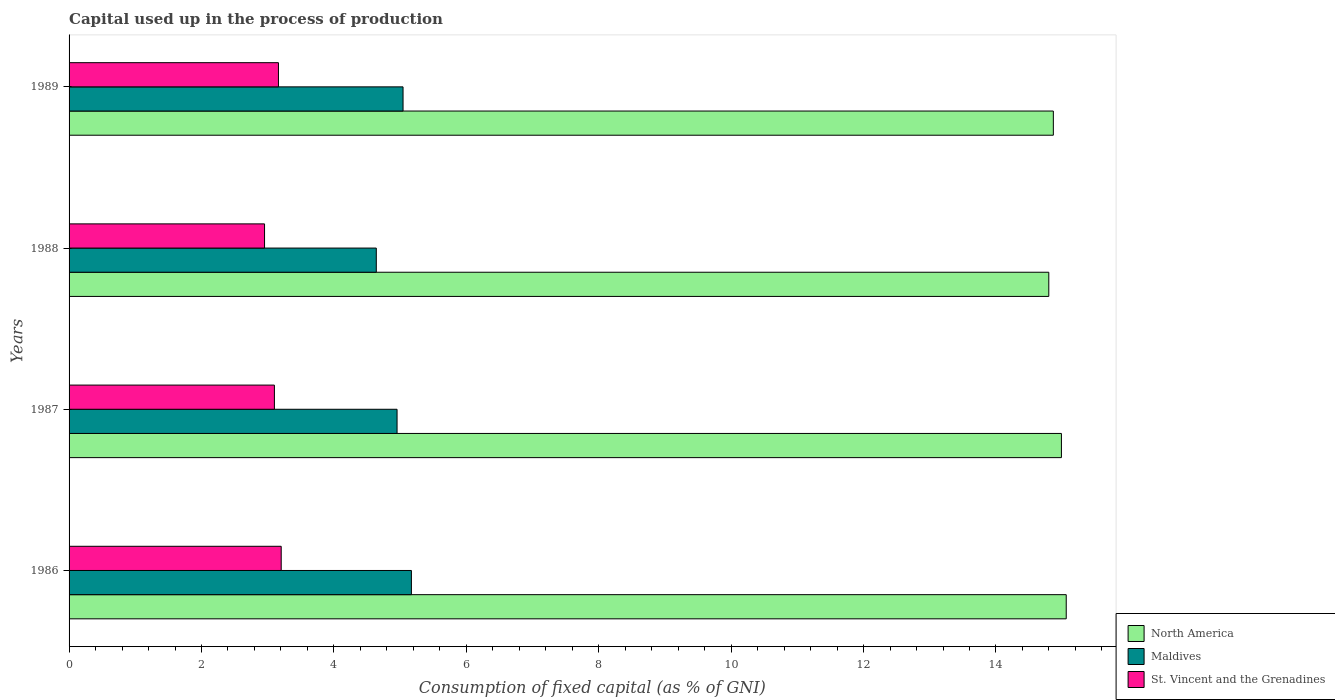How many groups of bars are there?
Your response must be concise. 4. How many bars are there on the 2nd tick from the top?
Give a very brief answer. 3. How many bars are there on the 4th tick from the bottom?
Ensure brevity in your answer.  3. What is the label of the 1st group of bars from the top?
Give a very brief answer. 1989. In how many cases, is the number of bars for a given year not equal to the number of legend labels?
Ensure brevity in your answer.  0. What is the capital used up in the process of production in Maldives in 1986?
Offer a terse response. 5.17. Across all years, what is the maximum capital used up in the process of production in North America?
Your answer should be very brief. 15.06. Across all years, what is the minimum capital used up in the process of production in North America?
Give a very brief answer. 14.8. In which year was the capital used up in the process of production in North America maximum?
Ensure brevity in your answer.  1986. In which year was the capital used up in the process of production in St. Vincent and the Grenadines minimum?
Offer a terse response. 1988. What is the total capital used up in the process of production in North America in the graph?
Keep it short and to the point. 59.71. What is the difference between the capital used up in the process of production in North America in 1988 and that in 1989?
Give a very brief answer. -0.07. What is the difference between the capital used up in the process of production in Maldives in 1987 and the capital used up in the process of production in St. Vincent and the Grenadines in 1986?
Provide a short and direct response. 1.75. What is the average capital used up in the process of production in St. Vincent and the Grenadines per year?
Provide a short and direct response. 3.11. In the year 1989, what is the difference between the capital used up in the process of production in North America and capital used up in the process of production in Maldives?
Give a very brief answer. 9.82. What is the ratio of the capital used up in the process of production in Maldives in 1986 to that in 1987?
Offer a terse response. 1.04. Is the capital used up in the process of production in Maldives in 1988 less than that in 1989?
Give a very brief answer. Yes. What is the difference between the highest and the second highest capital used up in the process of production in North America?
Provide a succinct answer. 0.07. What is the difference between the highest and the lowest capital used up in the process of production in Maldives?
Your response must be concise. 0.53. Is the sum of the capital used up in the process of production in Maldives in 1987 and 1988 greater than the maximum capital used up in the process of production in North America across all years?
Give a very brief answer. No. What does the 3rd bar from the top in 1986 represents?
Your answer should be compact. North America. What does the 1st bar from the bottom in 1987 represents?
Ensure brevity in your answer.  North America. Is it the case that in every year, the sum of the capital used up in the process of production in North America and capital used up in the process of production in Maldives is greater than the capital used up in the process of production in St. Vincent and the Grenadines?
Ensure brevity in your answer.  Yes. How many years are there in the graph?
Your answer should be very brief. 4. Are the values on the major ticks of X-axis written in scientific E-notation?
Offer a very short reply. No. Does the graph contain grids?
Your answer should be compact. No. How are the legend labels stacked?
Make the answer very short. Vertical. What is the title of the graph?
Offer a very short reply. Capital used up in the process of production. What is the label or title of the X-axis?
Provide a succinct answer. Consumption of fixed capital (as % of GNI). What is the label or title of the Y-axis?
Your answer should be compact. Years. What is the Consumption of fixed capital (as % of GNI) in North America in 1986?
Provide a short and direct response. 15.06. What is the Consumption of fixed capital (as % of GNI) in Maldives in 1986?
Provide a succinct answer. 5.17. What is the Consumption of fixed capital (as % of GNI) in St. Vincent and the Grenadines in 1986?
Your answer should be compact. 3.2. What is the Consumption of fixed capital (as % of GNI) of North America in 1987?
Ensure brevity in your answer.  14.99. What is the Consumption of fixed capital (as % of GNI) of Maldives in 1987?
Offer a very short reply. 4.95. What is the Consumption of fixed capital (as % of GNI) of St. Vincent and the Grenadines in 1987?
Your response must be concise. 3.1. What is the Consumption of fixed capital (as % of GNI) of North America in 1988?
Ensure brevity in your answer.  14.8. What is the Consumption of fixed capital (as % of GNI) in Maldives in 1988?
Your answer should be compact. 4.64. What is the Consumption of fixed capital (as % of GNI) of St. Vincent and the Grenadines in 1988?
Your answer should be compact. 2.95. What is the Consumption of fixed capital (as % of GNI) of North America in 1989?
Provide a succinct answer. 14.87. What is the Consumption of fixed capital (as % of GNI) in Maldives in 1989?
Offer a very short reply. 5.04. What is the Consumption of fixed capital (as % of GNI) of St. Vincent and the Grenadines in 1989?
Your answer should be very brief. 3.16. Across all years, what is the maximum Consumption of fixed capital (as % of GNI) in North America?
Give a very brief answer. 15.06. Across all years, what is the maximum Consumption of fixed capital (as % of GNI) of Maldives?
Provide a short and direct response. 5.17. Across all years, what is the maximum Consumption of fixed capital (as % of GNI) in St. Vincent and the Grenadines?
Offer a very short reply. 3.2. Across all years, what is the minimum Consumption of fixed capital (as % of GNI) of North America?
Offer a very short reply. 14.8. Across all years, what is the minimum Consumption of fixed capital (as % of GNI) of Maldives?
Provide a short and direct response. 4.64. Across all years, what is the minimum Consumption of fixed capital (as % of GNI) in St. Vincent and the Grenadines?
Offer a very short reply. 2.95. What is the total Consumption of fixed capital (as % of GNI) of North America in the graph?
Make the answer very short. 59.71. What is the total Consumption of fixed capital (as % of GNI) in Maldives in the graph?
Keep it short and to the point. 19.81. What is the total Consumption of fixed capital (as % of GNI) of St. Vincent and the Grenadines in the graph?
Give a very brief answer. 12.42. What is the difference between the Consumption of fixed capital (as % of GNI) of North America in 1986 and that in 1987?
Keep it short and to the point. 0.07. What is the difference between the Consumption of fixed capital (as % of GNI) of Maldives in 1986 and that in 1987?
Provide a short and direct response. 0.22. What is the difference between the Consumption of fixed capital (as % of GNI) in St. Vincent and the Grenadines in 1986 and that in 1987?
Offer a terse response. 0.1. What is the difference between the Consumption of fixed capital (as % of GNI) in North America in 1986 and that in 1988?
Your answer should be very brief. 0.26. What is the difference between the Consumption of fixed capital (as % of GNI) in Maldives in 1986 and that in 1988?
Provide a short and direct response. 0.53. What is the difference between the Consumption of fixed capital (as % of GNI) of St. Vincent and the Grenadines in 1986 and that in 1988?
Offer a terse response. 0.25. What is the difference between the Consumption of fixed capital (as % of GNI) of North America in 1986 and that in 1989?
Give a very brief answer. 0.19. What is the difference between the Consumption of fixed capital (as % of GNI) of Maldives in 1986 and that in 1989?
Your answer should be compact. 0.13. What is the difference between the Consumption of fixed capital (as % of GNI) of St. Vincent and the Grenadines in 1986 and that in 1989?
Your response must be concise. 0.04. What is the difference between the Consumption of fixed capital (as % of GNI) of North America in 1987 and that in 1988?
Ensure brevity in your answer.  0.19. What is the difference between the Consumption of fixed capital (as % of GNI) in Maldives in 1987 and that in 1988?
Offer a terse response. 0.31. What is the difference between the Consumption of fixed capital (as % of GNI) in St. Vincent and the Grenadines in 1987 and that in 1988?
Your response must be concise. 0.15. What is the difference between the Consumption of fixed capital (as % of GNI) of North America in 1987 and that in 1989?
Your answer should be very brief. 0.12. What is the difference between the Consumption of fixed capital (as % of GNI) of Maldives in 1987 and that in 1989?
Keep it short and to the point. -0.09. What is the difference between the Consumption of fixed capital (as % of GNI) in St. Vincent and the Grenadines in 1987 and that in 1989?
Provide a succinct answer. -0.06. What is the difference between the Consumption of fixed capital (as % of GNI) in North America in 1988 and that in 1989?
Ensure brevity in your answer.  -0.07. What is the difference between the Consumption of fixed capital (as % of GNI) of Maldives in 1988 and that in 1989?
Make the answer very short. -0.4. What is the difference between the Consumption of fixed capital (as % of GNI) of St. Vincent and the Grenadines in 1988 and that in 1989?
Your answer should be compact. -0.21. What is the difference between the Consumption of fixed capital (as % of GNI) of North America in 1986 and the Consumption of fixed capital (as % of GNI) of Maldives in 1987?
Give a very brief answer. 10.11. What is the difference between the Consumption of fixed capital (as % of GNI) in North America in 1986 and the Consumption of fixed capital (as % of GNI) in St. Vincent and the Grenadines in 1987?
Your answer should be compact. 11.96. What is the difference between the Consumption of fixed capital (as % of GNI) in Maldives in 1986 and the Consumption of fixed capital (as % of GNI) in St. Vincent and the Grenadines in 1987?
Keep it short and to the point. 2.07. What is the difference between the Consumption of fixed capital (as % of GNI) in North America in 1986 and the Consumption of fixed capital (as % of GNI) in Maldives in 1988?
Your answer should be compact. 10.42. What is the difference between the Consumption of fixed capital (as % of GNI) in North America in 1986 and the Consumption of fixed capital (as % of GNI) in St. Vincent and the Grenadines in 1988?
Make the answer very short. 12.11. What is the difference between the Consumption of fixed capital (as % of GNI) of Maldives in 1986 and the Consumption of fixed capital (as % of GNI) of St. Vincent and the Grenadines in 1988?
Give a very brief answer. 2.22. What is the difference between the Consumption of fixed capital (as % of GNI) in North America in 1986 and the Consumption of fixed capital (as % of GNI) in Maldives in 1989?
Make the answer very short. 10.02. What is the difference between the Consumption of fixed capital (as % of GNI) of North America in 1986 and the Consumption of fixed capital (as % of GNI) of St. Vincent and the Grenadines in 1989?
Offer a very short reply. 11.9. What is the difference between the Consumption of fixed capital (as % of GNI) in Maldives in 1986 and the Consumption of fixed capital (as % of GNI) in St. Vincent and the Grenadines in 1989?
Offer a very short reply. 2.01. What is the difference between the Consumption of fixed capital (as % of GNI) in North America in 1987 and the Consumption of fixed capital (as % of GNI) in Maldives in 1988?
Offer a terse response. 10.35. What is the difference between the Consumption of fixed capital (as % of GNI) of North America in 1987 and the Consumption of fixed capital (as % of GNI) of St. Vincent and the Grenadines in 1988?
Your answer should be compact. 12.04. What is the difference between the Consumption of fixed capital (as % of GNI) of Maldives in 1987 and the Consumption of fixed capital (as % of GNI) of St. Vincent and the Grenadines in 1988?
Ensure brevity in your answer.  2. What is the difference between the Consumption of fixed capital (as % of GNI) of North America in 1987 and the Consumption of fixed capital (as % of GNI) of Maldives in 1989?
Offer a terse response. 9.94. What is the difference between the Consumption of fixed capital (as % of GNI) in North America in 1987 and the Consumption of fixed capital (as % of GNI) in St. Vincent and the Grenadines in 1989?
Keep it short and to the point. 11.83. What is the difference between the Consumption of fixed capital (as % of GNI) in Maldives in 1987 and the Consumption of fixed capital (as % of GNI) in St. Vincent and the Grenadines in 1989?
Provide a succinct answer. 1.79. What is the difference between the Consumption of fixed capital (as % of GNI) in North America in 1988 and the Consumption of fixed capital (as % of GNI) in Maldives in 1989?
Provide a succinct answer. 9.75. What is the difference between the Consumption of fixed capital (as % of GNI) in North America in 1988 and the Consumption of fixed capital (as % of GNI) in St. Vincent and the Grenadines in 1989?
Ensure brevity in your answer.  11.64. What is the difference between the Consumption of fixed capital (as % of GNI) of Maldives in 1988 and the Consumption of fixed capital (as % of GNI) of St. Vincent and the Grenadines in 1989?
Offer a very short reply. 1.48. What is the average Consumption of fixed capital (as % of GNI) in North America per year?
Your response must be concise. 14.93. What is the average Consumption of fixed capital (as % of GNI) of Maldives per year?
Your response must be concise. 4.95. What is the average Consumption of fixed capital (as % of GNI) of St. Vincent and the Grenadines per year?
Give a very brief answer. 3.11. In the year 1986, what is the difference between the Consumption of fixed capital (as % of GNI) of North America and Consumption of fixed capital (as % of GNI) of Maldives?
Give a very brief answer. 9.89. In the year 1986, what is the difference between the Consumption of fixed capital (as % of GNI) of North America and Consumption of fixed capital (as % of GNI) of St. Vincent and the Grenadines?
Provide a short and direct response. 11.86. In the year 1986, what is the difference between the Consumption of fixed capital (as % of GNI) of Maldives and Consumption of fixed capital (as % of GNI) of St. Vincent and the Grenadines?
Your answer should be compact. 1.97. In the year 1987, what is the difference between the Consumption of fixed capital (as % of GNI) of North America and Consumption of fixed capital (as % of GNI) of Maldives?
Your answer should be compact. 10.03. In the year 1987, what is the difference between the Consumption of fixed capital (as % of GNI) in North America and Consumption of fixed capital (as % of GNI) in St. Vincent and the Grenadines?
Your answer should be very brief. 11.89. In the year 1987, what is the difference between the Consumption of fixed capital (as % of GNI) of Maldives and Consumption of fixed capital (as % of GNI) of St. Vincent and the Grenadines?
Give a very brief answer. 1.85. In the year 1988, what is the difference between the Consumption of fixed capital (as % of GNI) in North America and Consumption of fixed capital (as % of GNI) in Maldives?
Your response must be concise. 10.16. In the year 1988, what is the difference between the Consumption of fixed capital (as % of GNI) in North America and Consumption of fixed capital (as % of GNI) in St. Vincent and the Grenadines?
Your answer should be compact. 11.85. In the year 1988, what is the difference between the Consumption of fixed capital (as % of GNI) in Maldives and Consumption of fixed capital (as % of GNI) in St. Vincent and the Grenadines?
Your response must be concise. 1.69. In the year 1989, what is the difference between the Consumption of fixed capital (as % of GNI) in North America and Consumption of fixed capital (as % of GNI) in Maldives?
Your answer should be compact. 9.82. In the year 1989, what is the difference between the Consumption of fixed capital (as % of GNI) in North America and Consumption of fixed capital (as % of GNI) in St. Vincent and the Grenadines?
Your answer should be compact. 11.7. In the year 1989, what is the difference between the Consumption of fixed capital (as % of GNI) in Maldives and Consumption of fixed capital (as % of GNI) in St. Vincent and the Grenadines?
Your answer should be compact. 1.88. What is the ratio of the Consumption of fixed capital (as % of GNI) of North America in 1986 to that in 1987?
Your response must be concise. 1. What is the ratio of the Consumption of fixed capital (as % of GNI) in Maldives in 1986 to that in 1987?
Your response must be concise. 1.04. What is the ratio of the Consumption of fixed capital (as % of GNI) of St. Vincent and the Grenadines in 1986 to that in 1987?
Provide a succinct answer. 1.03. What is the ratio of the Consumption of fixed capital (as % of GNI) of North America in 1986 to that in 1988?
Give a very brief answer. 1.02. What is the ratio of the Consumption of fixed capital (as % of GNI) of Maldives in 1986 to that in 1988?
Your response must be concise. 1.11. What is the ratio of the Consumption of fixed capital (as % of GNI) of St. Vincent and the Grenadines in 1986 to that in 1988?
Your answer should be compact. 1.09. What is the ratio of the Consumption of fixed capital (as % of GNI) in North America in 1986 to that in 1989?
Offer a terse response. 1.01. What is the ratio of the Consumption of fixed capital (as % of GNI) in Maldives in 1986 to that in 1989?
Provide a succinct answer. 1.02. What is the ratio of the Consumption of fixed capital (as % of GNI) of St. Vincent and the Grenadines in 1986 to that in 1989?
Offer a terse response. 1.01. What is the ratio of the Consumption of fixed capital (as % of GNI) in North America in 1987 to that in 1988?
Ensure brevity in your answer.  1.01. What is the ratio of the Consumption of fixed capital (as % of GNI) of Maldives in 1987 to that in 1988?
Provide a short and direct response. 1.07. What is the ratio of the Consumption of fixed capital (as % of GNI) of St. Vincent and the Grenadines in 1987 to that in 1988?
Your answer should be compact. 1.05. What is the ratio of the Consumption of fixed capital (as % of GNI) of North America in 1987 to that in 1989?
Make the answer very short. 1.01. What is the ratio of the Consumption of fixed capital (as % of GNI) of Maldives in 1987 to that in 1989?
Provide a short and direct response. 0.98. What is the ratio of the Consumption of fixed capital (as % of GNI) in St. Vincent and the Grenadines in 1987 to that in 1989?
Make the answer very short. 0.98. What is the ratio of the Consumption of fixed capital (as % of GNI) of Maldives in 1988 to that in 1989?
Your answer should be compact. 0.92. What is the ratio of the Consumption of fixed capital (as % of GNI) of St. Vincent and the Grenadines in 1988 to that in 1989?
Your response must be concise. 0.93. What is the difference between the highest and the second highest Consumption of fixed capital (as % of GNI) in North America?
Your answer should be compact. 0.07. What is the difference between the highest and the second highest Consumption of fixed capital (as % of GNI) of Maldives?
Offer a terse response. 0.13. What is the difference between the highest and the second highest Consumption of fixed capital (as % of GNI) of St. Vincent and the Grenadines?
Provide a succinct answer. 0.04. What is the difference between the highest and the lowest Consumption of fixed capital (as % of GNI) of North America?
Make the answer very short. 0.26. What is the difference between the highest and the lowest Consumption of fixed capital (as % of GNI) of Maldives?
Give a very brief answer. 0.53. What is the difference between the highest and the lowest Consumption of fixed capital (as % of GNI) in St. Vincent and the Grenadines?
Make the answer very short. 0.25. 